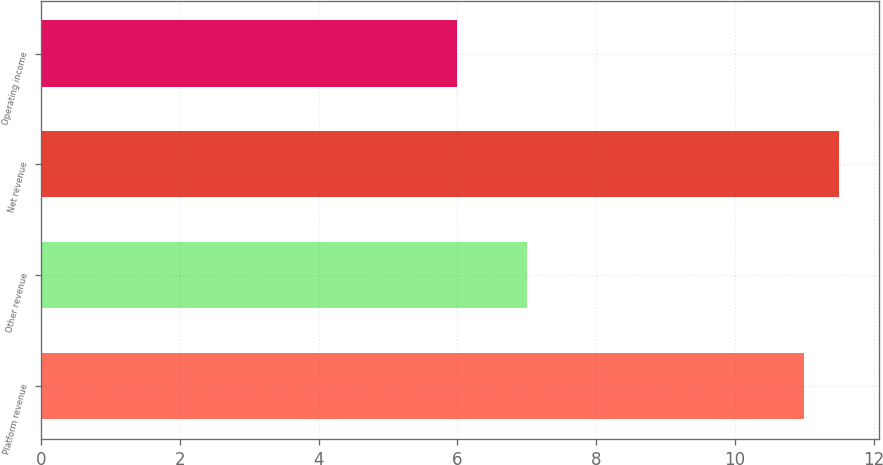<chart> <loc_0><loc_0><loc_500><loc_500><bar_chart><fcel>Platform revenue<fcel>Other revenue<fcel>Net revenue<fcel>Operating income<nl><fcel>11<fcel>7<fcel>11.5<fcel>6<nl></chart> 